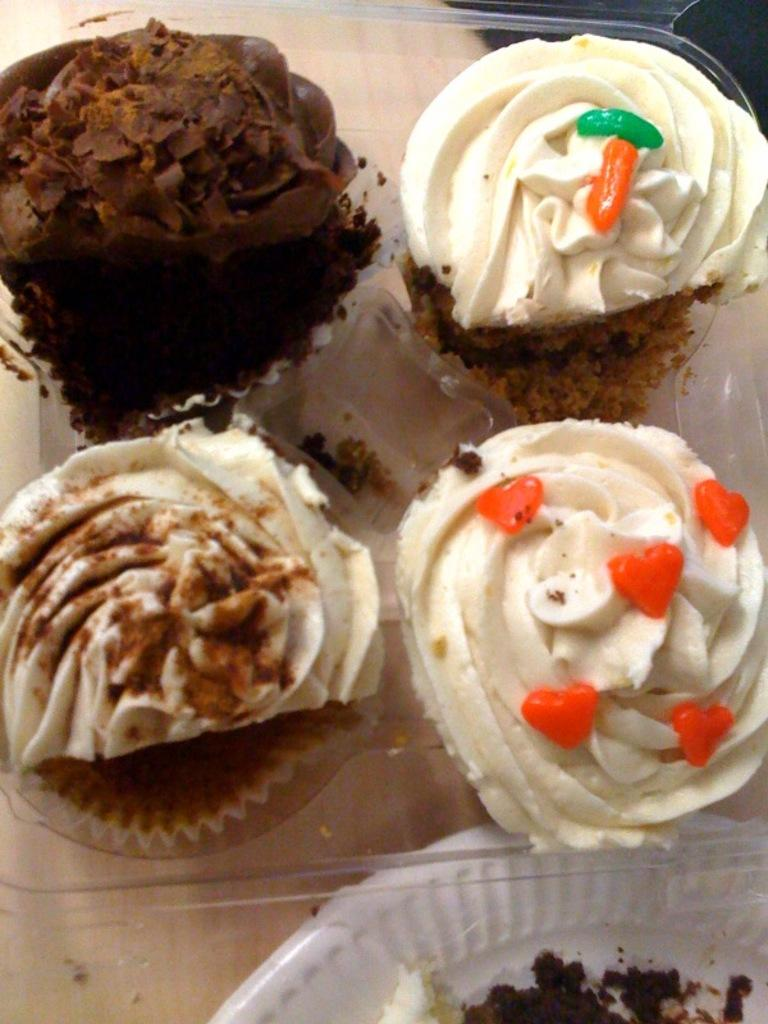What type of food is in the box in the image? There are muffins in a box in the image. What is the color of the plate in the image? There is a white plate in the image. What piece of furniture is present in the image? There is a table in the image. What type of roof can be seen on the table in the image? There is no roof present in the image, as the table is a piece of furniture and not a building. 